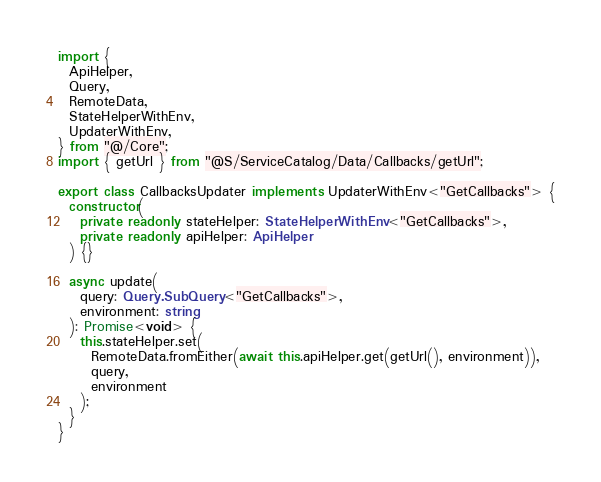Convert code to text. <code><loc_0><loc_0><loc_500><loc_500><_TypeScript_>import {
  ApiHelper,
  Query,
  RemoteData,
  StateHelperWithEnv,
  UpdaterWithEnv,
} from "@/Core";
import { getUrl } from "@S/ServiceCatalog/Data/Callbacks/getUrl";

export class CallbacksUpdater implements UpdaterWithEnv<"GetCallbacks"> {
  constructor(
    private readonly stateHelper: StateHelperWithEnv<"GetCallbacks">,
    private readonly apiHelper: ApiHelper
  ) {}

  async update(
    query: Query.SubQuery<"GetCallbacks">,
    environment: string
  ): Promise<void> {
    this.stateHelper.set(
      RemoteData.fromEither(await this.apiHelper.get(getUrl(), environment)),
      query,
      environment
    );
  }
}
</code> 